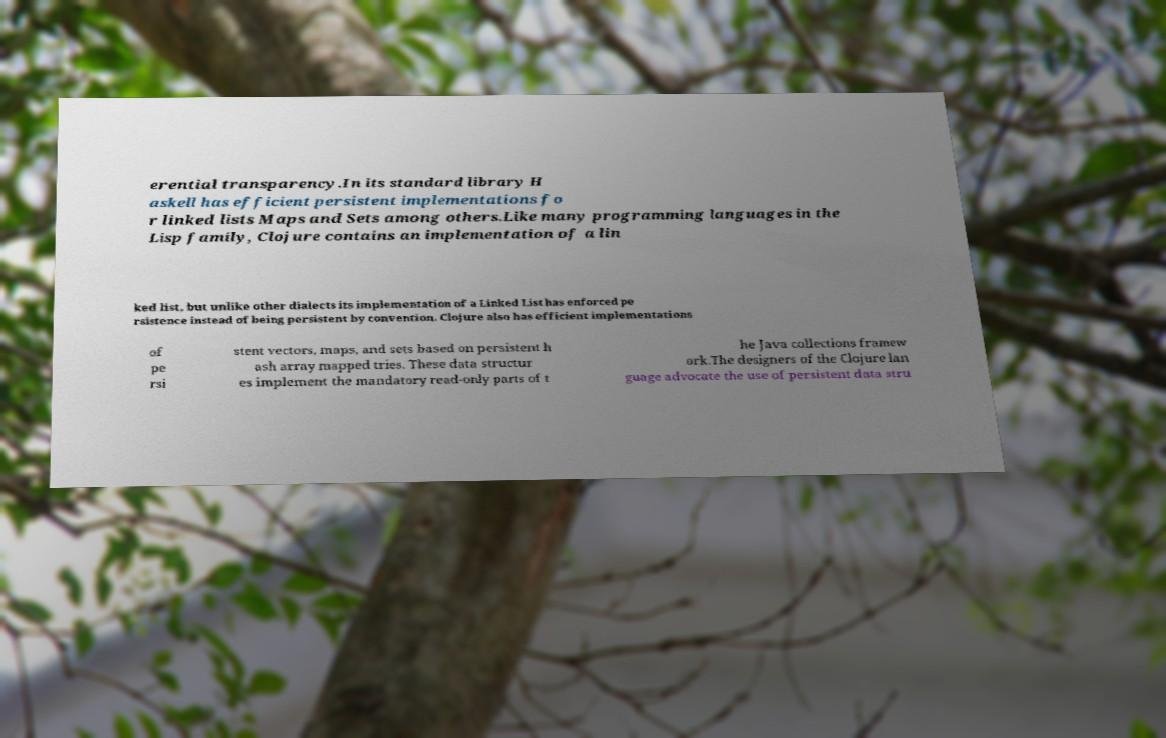For documentation purposes, I need the text within this image transcribed. Could you provide that? erential transparency.In its standard library H askell has efficient persistent implementations fo r linked lists Maps and Sets among others.Like many programming languages in the Lisp family, Clojure contains an implementation of a lin ked list, but unlike other dialects its implementation of a Linked List has enforced pe rsistence instead of being persistent by convention. Clojure also has efficient implementations of pe rsi stent vectors, maps, and sets based on persistent h ash array mapped tries. These data structur es implement the mandatory read-only parts of t he Java collections framew ork.The designers of the Clojure lan guage advocate the use of persistent data stru 